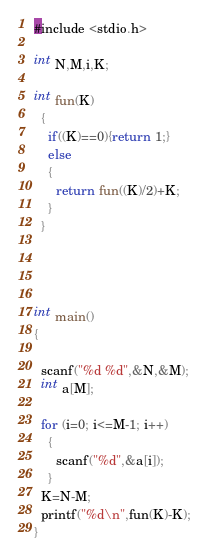Convert code to text. <code><loc_0><loc_0><loc_500><loc_500><_C#_>#include <stdio.h>

int N,M,i,K;

int fun(K)
  {
    if((K)==0){return 1;}
    else
    {
      return fun((K)/2)+K;
    }
  }




int main()
{

  scanf("%d %d",&N,&M);
  int a[M];

  for (i=0; i<=M-1; i++)
    {
      scanf("%d",&a[i]);
    }
  K=N-M;
  printf("%d\n",fun(K)-K);
}</code> 